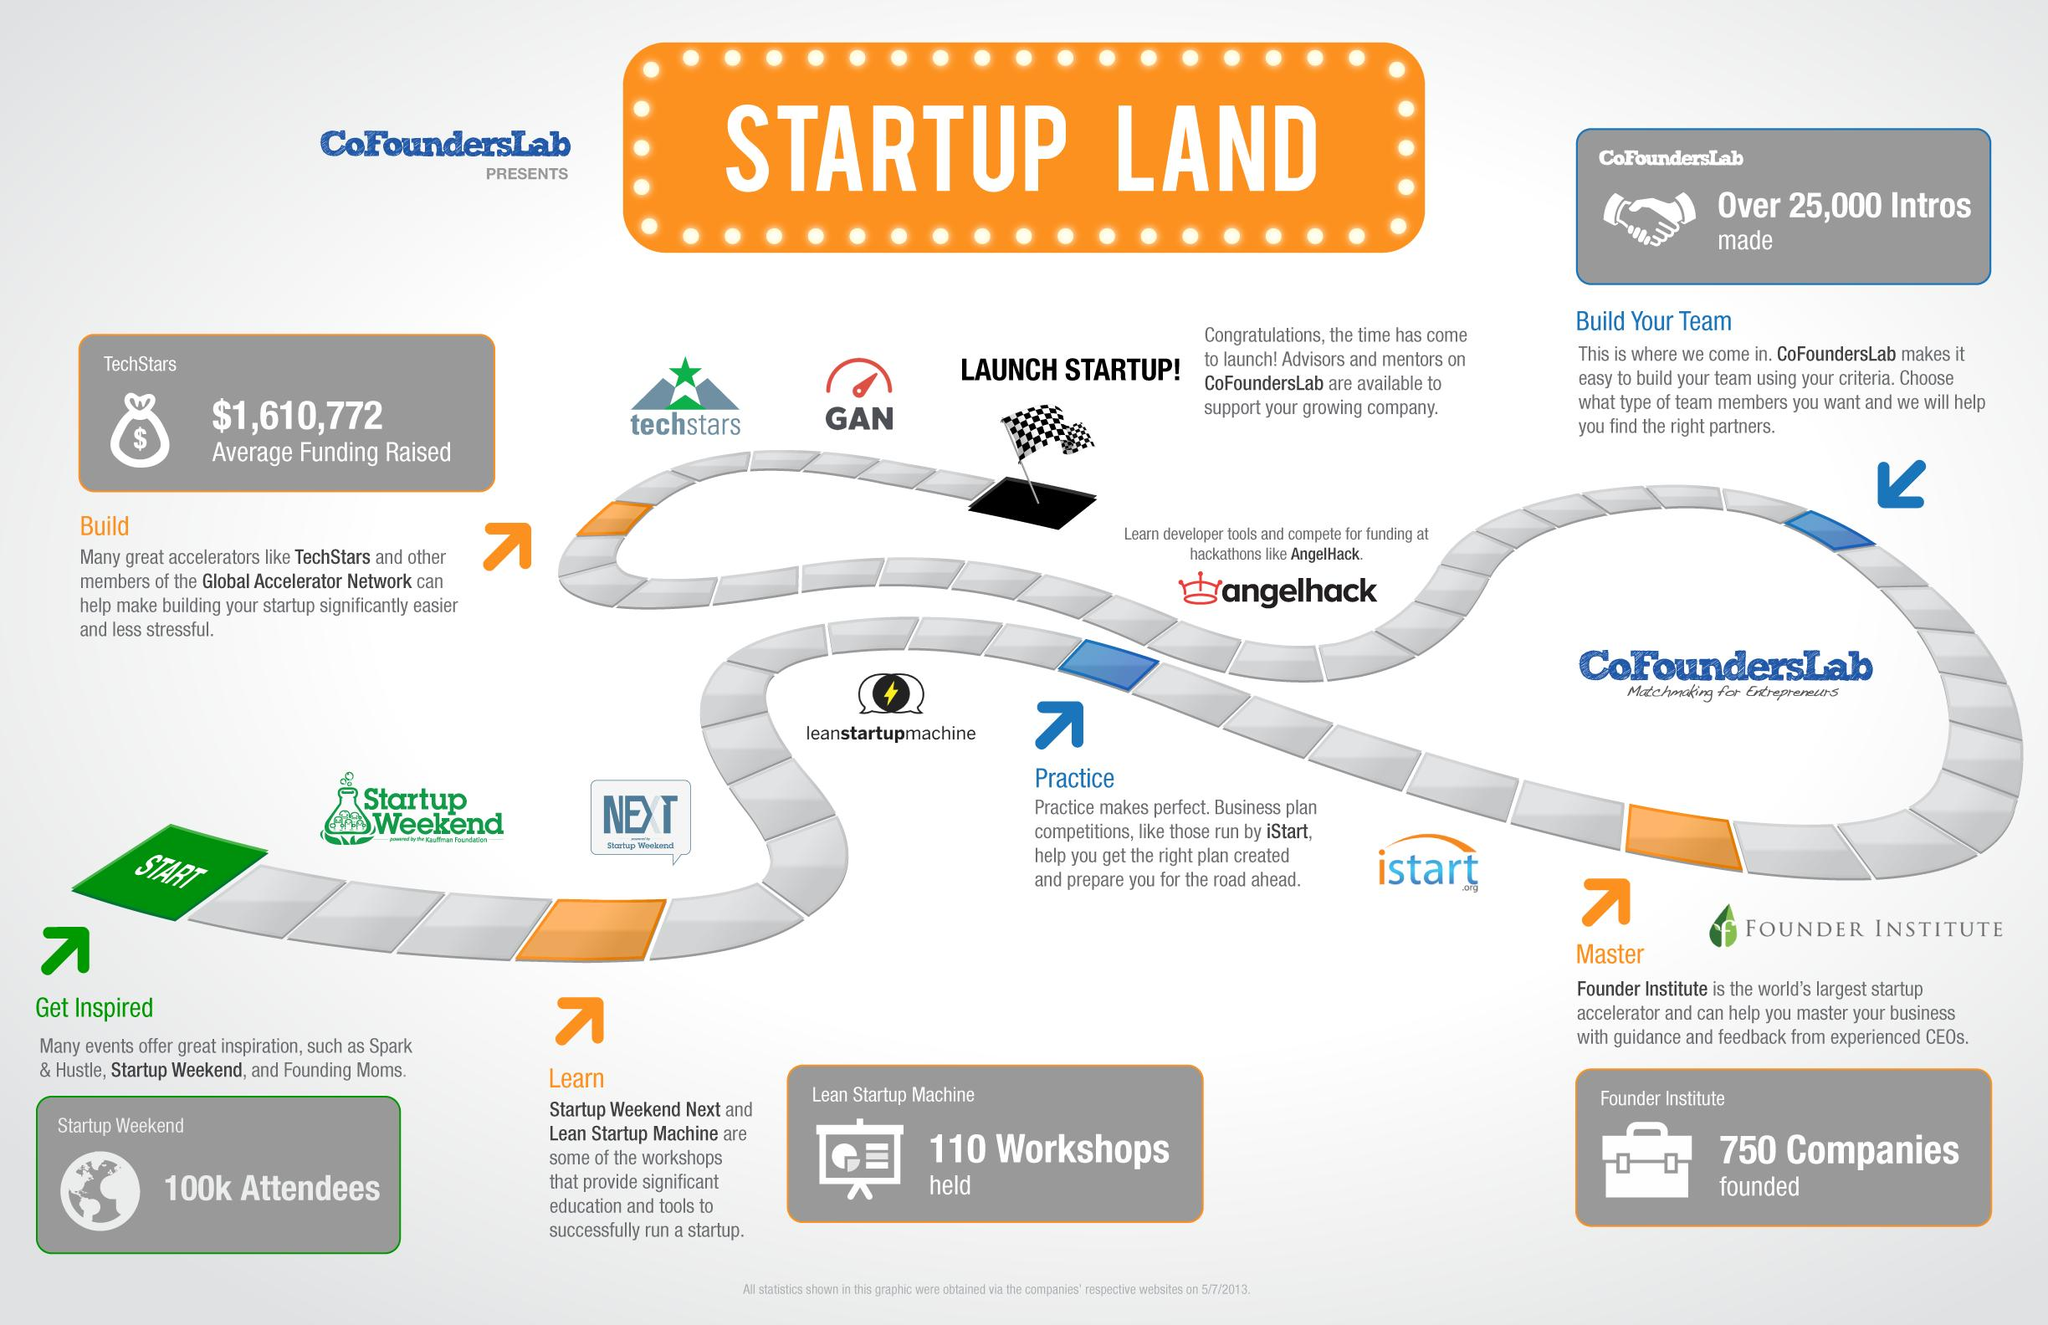Indicate a few pertinent items in this graphic. As of 5/7/2013, there were 100,000 attendees present at the 'Startup Weekend' event. The Founder Institute is recognized as the world's largest pre-seed startup accelerator. CofoundersLab will assist in finding the right partners to build the startup team and ultimately aid in the success of the company. According to information available as of May 7th, 2013, the average amount of funds raised by startups launched through the Techstars program was $1,610,772. As of May 7th, 2013, the Founder Institute had helped to establish 750 companies. 